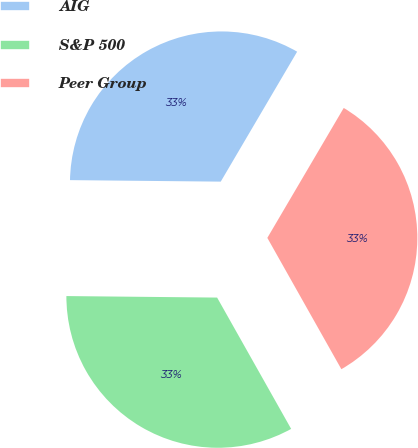Convert chart to OTSL. <chart><loc_0><loc_0><loc_500><loc_500><pie_chart><fcel>AIG<fcel>S&P 500<fcel>Peer Group<nl><fcel>33.3%<fcel>33.33%<fcel>33.37%<nl></chart> 